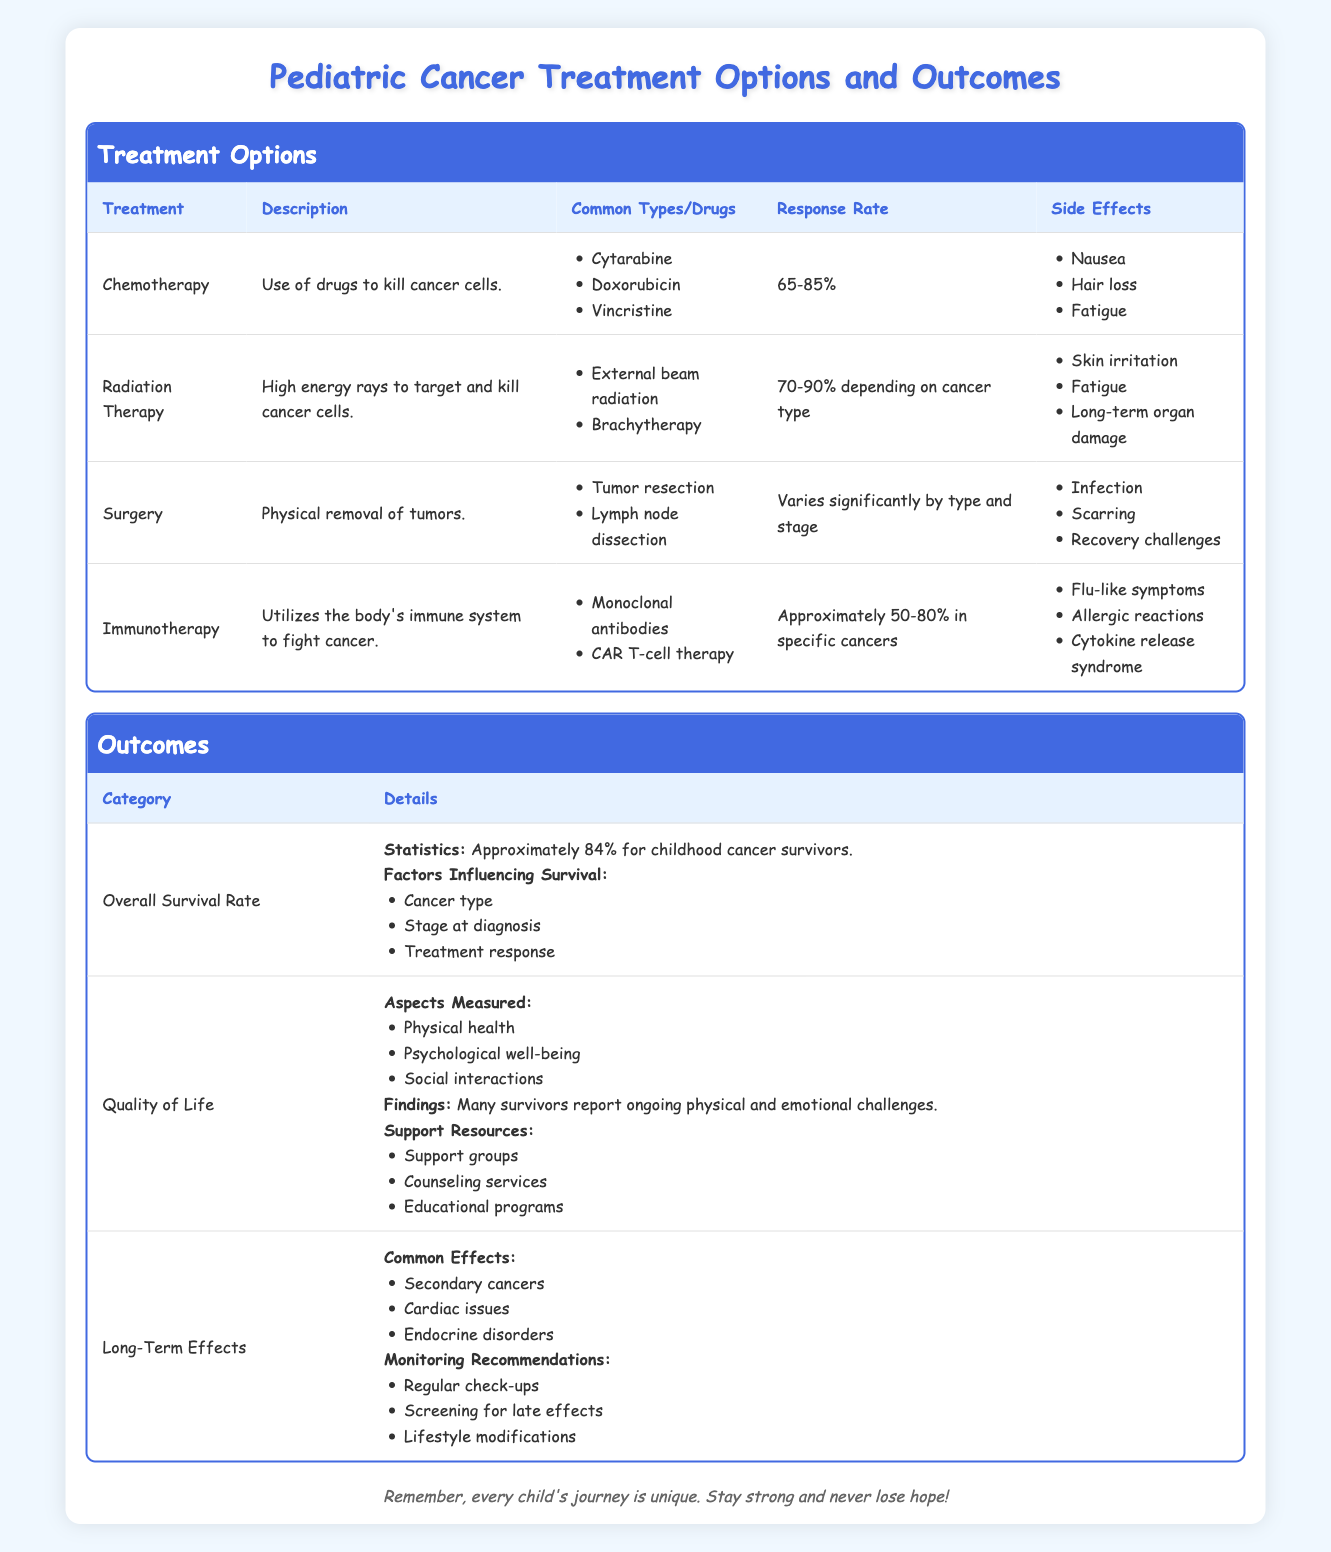What are the common drugs used in Chemotherapy? The table lists the common drugs used in Chemotherapy under the "Common Drugs" column. These drugs are Cytarabine, Doxorubicin, and Vincristine.
Answer: Cytarabine, Doxorubicin, Vincristine What is the response rate for Radiation Therapy? The response rate for Radiation Therapy can be found in the second treatment row under the "Response Rate" column. It is stated as 70-90% depending on cancer type.
Answer: 70-90% depending on cancer type Is it true that Immunotherapy uses the body's immune system to fight cancer? The description of Immunotherapy provided in the table confirms that it utilizes the body’s immune system to fight cancer and therefore, the statement is true.
Answer: True What are the side effects associated with Surgery? Side effects for Surgery are listed in the "Side Effects" column. They include Infection, Scarring, and Recovery challenges.
Answer: Infection, Scarring, Recovery challenges What is the average response rate range for Chemotherapy and Immunotherapy combined? The response rates for Chemotherapy (65-85%) and Immunotherapy (approximately 50-80%) need to be averaged. To get a rough average: (75 + 65 + 50 + 80) / 4 = 67.5% as a simplified average of the midpoint values of the ranges for both treatment types combined.
Answer: 67.5% What factors influence the overall survival rate for childhood cancer survivors? Factors influencing survival are listed under the "Overall Survival Rate" section. These include Cancer type, Stage at diagnosis, and Treatment response.
Answer: Cancer type, Stage at diagnosis, Treatment response What are the common long-term effects mentioned in the table? The common long-term effects from the "Long-Term Effects" section are listed as Secondary cancers, Cardiac issues, and Endocrine disorders.
Answer: Secondary cancers, Cardiac issues, Endocrine disorders For which treatment option is the response rate highly variable? The treatment option with a highly variable response rate is Surgery, as stated in the "Response Rate" column, which mentions it varies significantly by type and stage.
Answer: Surgery Do survivors report challenges in physical and emotional aspects post-treatment? The findings under the "Quality of Life" section state that many survivors report ongoing physical and emotional challenges, confirming the statement is true.
Answer: True 